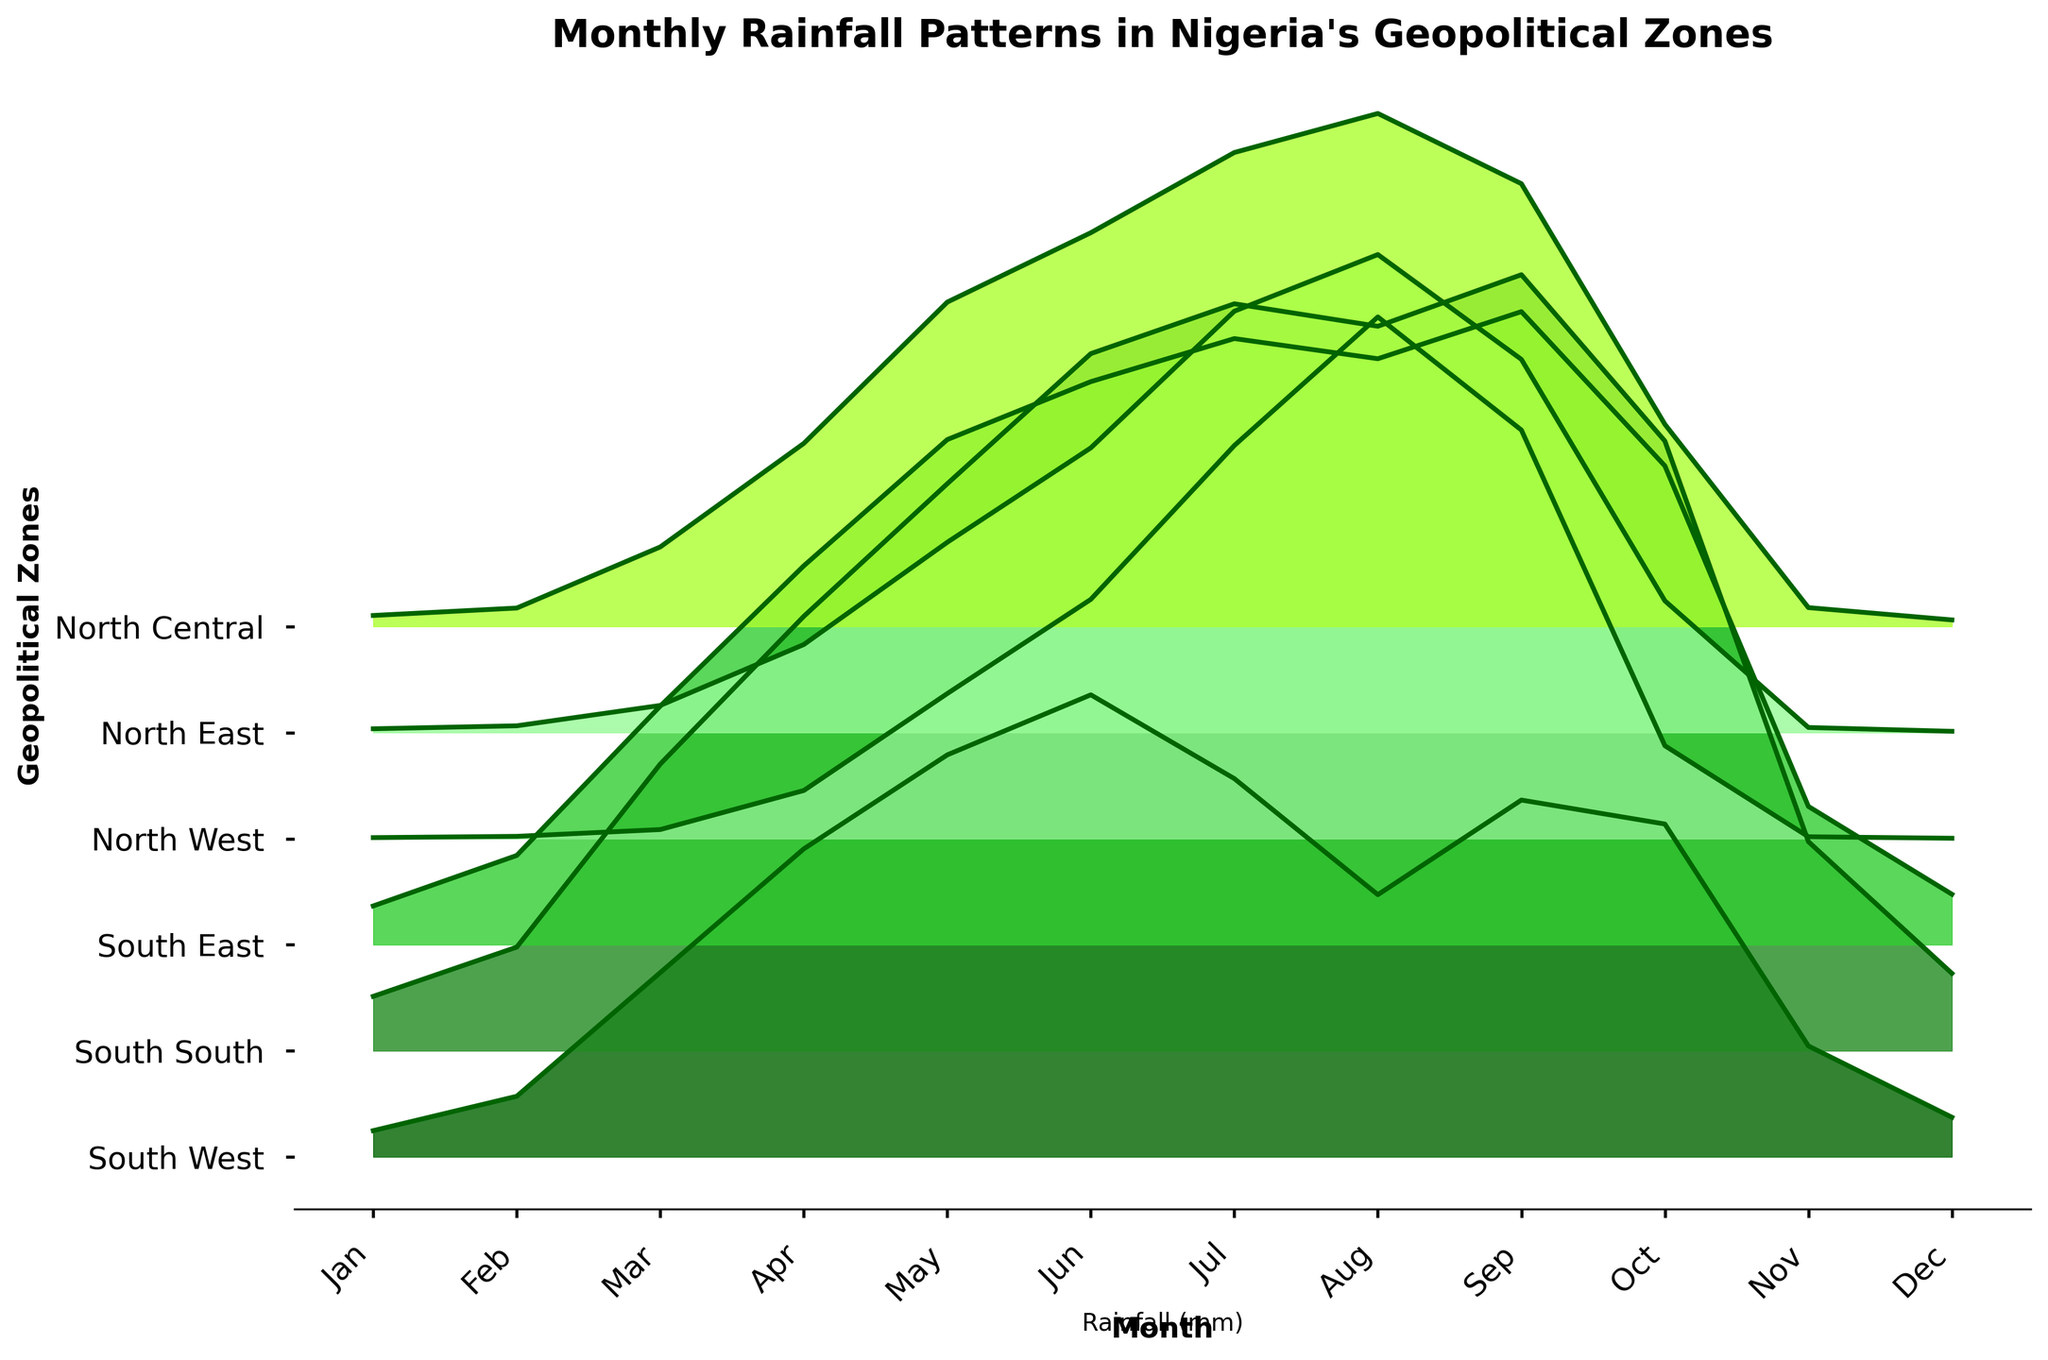What's the title of the figure? The title is usually located at the top of the figure. Here, it reads "Monthly Rainfall Patterns in Nigeria's Geopolitical Zones".
Answer: Monthly Rainfall Patterns in Nigeria's Geopolitical Zones Which month shows the highest rainfall in the North West zone? Look at the plot for the North West zone and observe the peak. The highest peak for North West is in August.
Answer: August How does the rainfall in the North East zone in February compare to July? Identify the height of the ridgeline in February and July for the North East zone. February has lower rainfall than July.
Answer: Lower in February Which geopolitical zone has the highest average rainfall in May? Compare the heights of the ridgelines for all zones in May. The South South zone shows the highest ridgeline peak.
Answer: South South Between which months does the North Central zone see the steepest increase in rainfall? Observe the monthly transitions in the ridgeline height for North Central. The steepest increase occurs between March and April.
Answer: March to April For the South West zone, in which months does the rainfall decrease compared to the previous month? Check each month's ridgeline height for South West and compare with the previous month's height. Decreases are noted from July to August and from October to December.
Answer: July to August, October to December In which month does the South East zone experience the peak rainfall? Identify the month with the highest peak in the South East zone's ridgeline. The peak is in September.
Answer: September What is the difference in rainfall between June and November for the South South zone? Compare the ridgeline heights in June and November for the South South zone, then subtract the November value from the June value. Difference: 328.6 - 98.6 = 230 mm
Answer: 230 mm Which zone exhibits the least variation in rainfall throughout the year? Observe the smoothness and consistency of the ridgelines across months for all zones. The North West zone shows the least variation.
Answer: North West How does the January rainfall in South East compare to the December rainfall in the same zone? Compare the ridgeline heights for January and December in the South East zone. January has higher rainfall than December.
Answer: Higher in January 